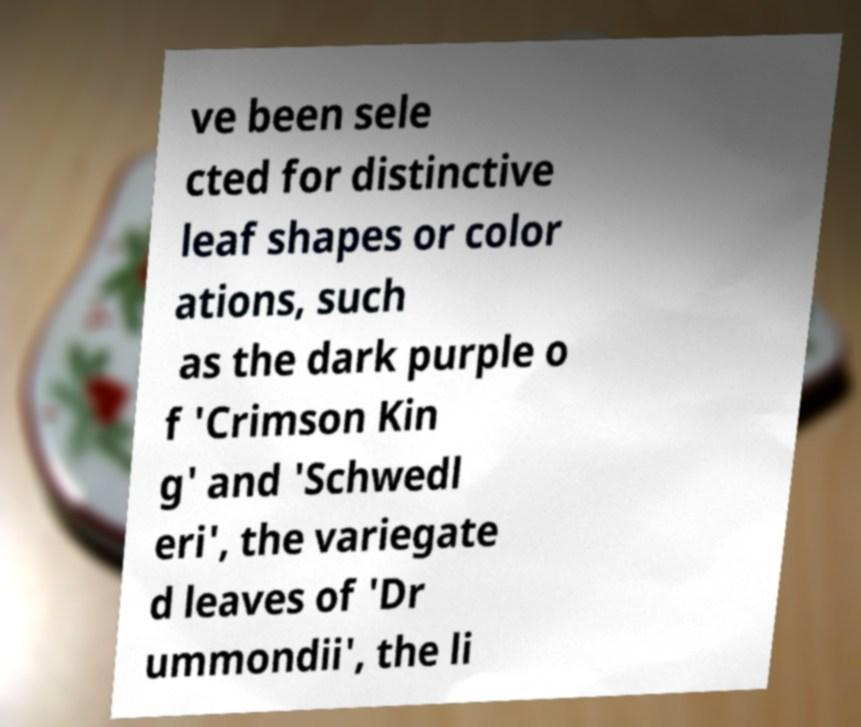Please read and relay the text visible in this image. What does it say? ve been sele cted for distinctive leaf shapes or color ations, such as the dark purple o f 'Crimson Kin g' and 'Schwedl eri', the variegate d leaves of 'Dr ummondii', the li 